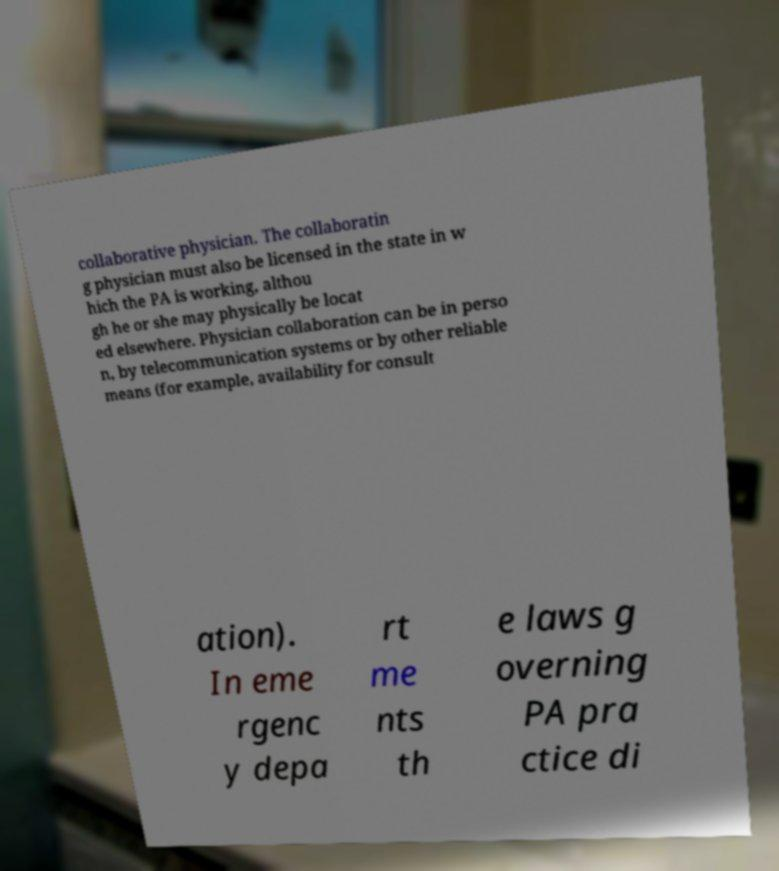What messages or text are displayed in this image? I need them in a readable, typed format. collaborative physician. The collaboratin g physician must also be licensed in the state in w hich the PA is working, althou gh he or she may physically be locat ed elsewhere. Physician collaboration can be in perso n, by telecommunication systems or by other reliable means (for example, availability for consult ation). In eme rgenc y depa rt me nts th e laws g overning PA pra ctice di 